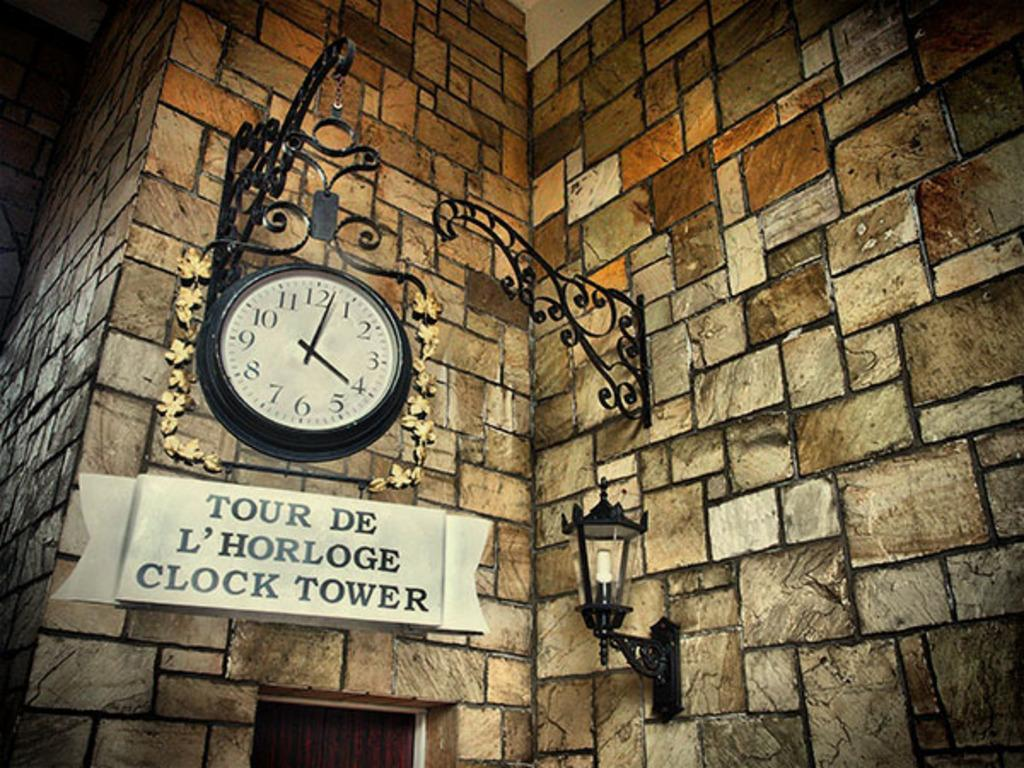<image>
Share a concise interpretation of the image provided. Clock above a sign which says "Tour De L'Horloge Clock Tower". 